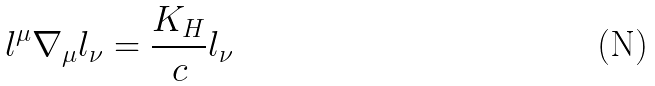<formula> <loc_0><loc_0><loc_500><loc_500>l ^ { \mu } \nabla _ { \mu } l _ { \nu } = \frac { K _ { H } } { c } l _ { \nu }</formula> 